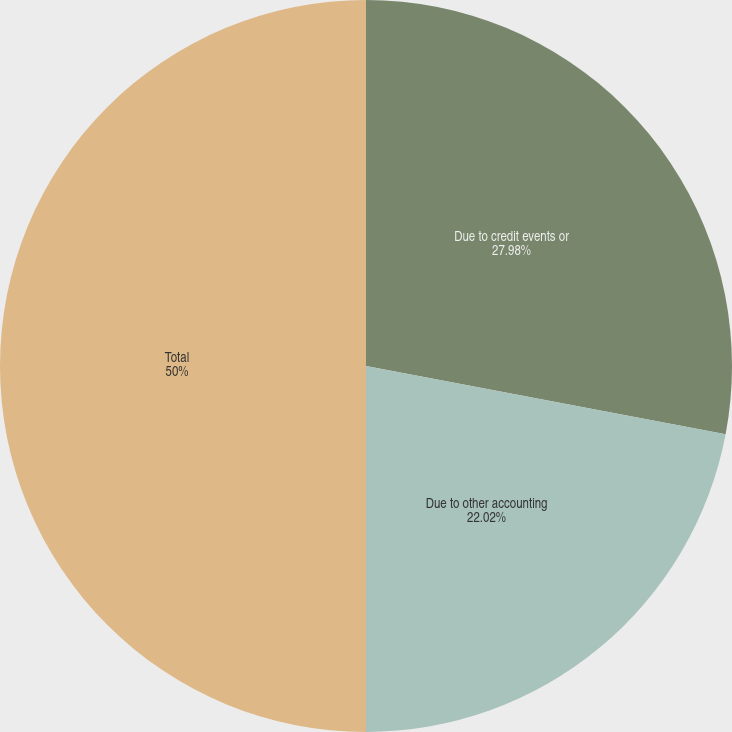Convert chart to OTSL. <chart><loc_0><loc_0><loc_500><loc_500><pie_chart><fcel>Due to credit events or<fcel>Due to other accounting<fcel>Total<nl><fcel>27.98%<fcel>22.02%<fcel>50.0%<nl></chart> 